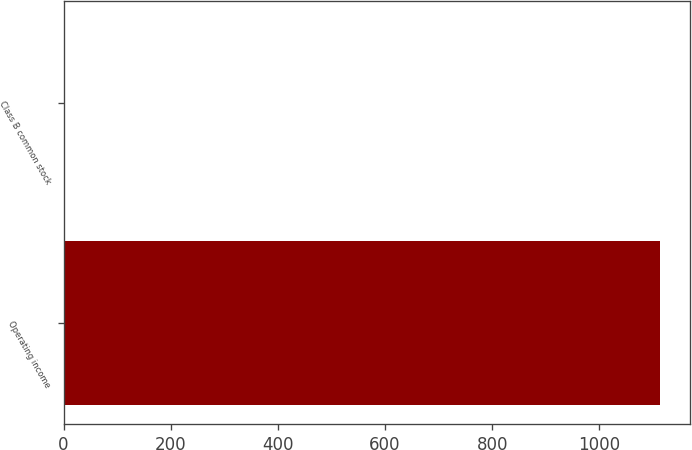Convert chart to OTSL. <chart><loc_0><loc_0><loc_500><loc_500><bar_chart><fcel>Operating income<fcel>Class B common stock<nl><fcel>1113<fcel>0.59<nl></chart> 